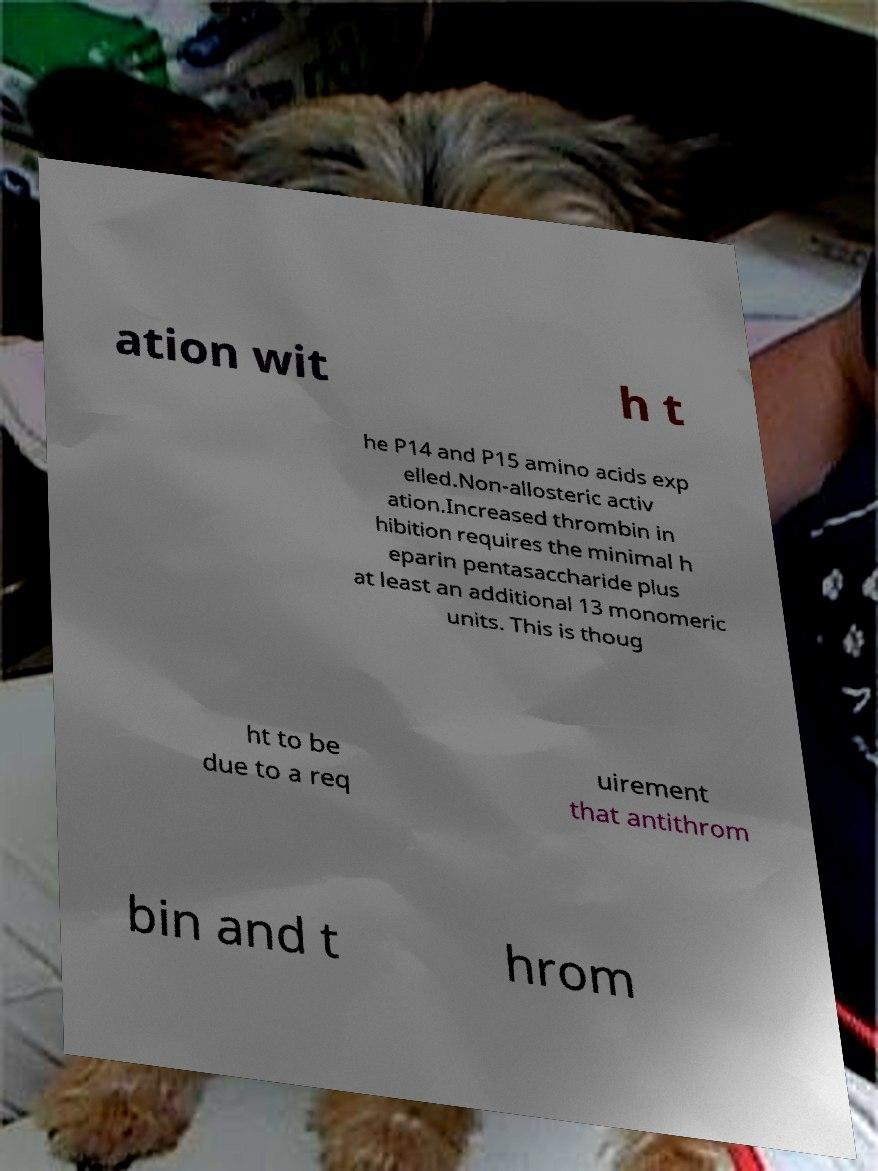I need the written content from this picture converted into text. Can you do that? ation wit h t he P14 and P15 amino acids exp elled.Non-allosteric activ ation.Increased thrombin in hibition requires the minimal h eparin pentasaccharide plus at least an additional 13 monomeric units. This is thoug ht to be due to a req uirement that antithrom bin and t hrom 